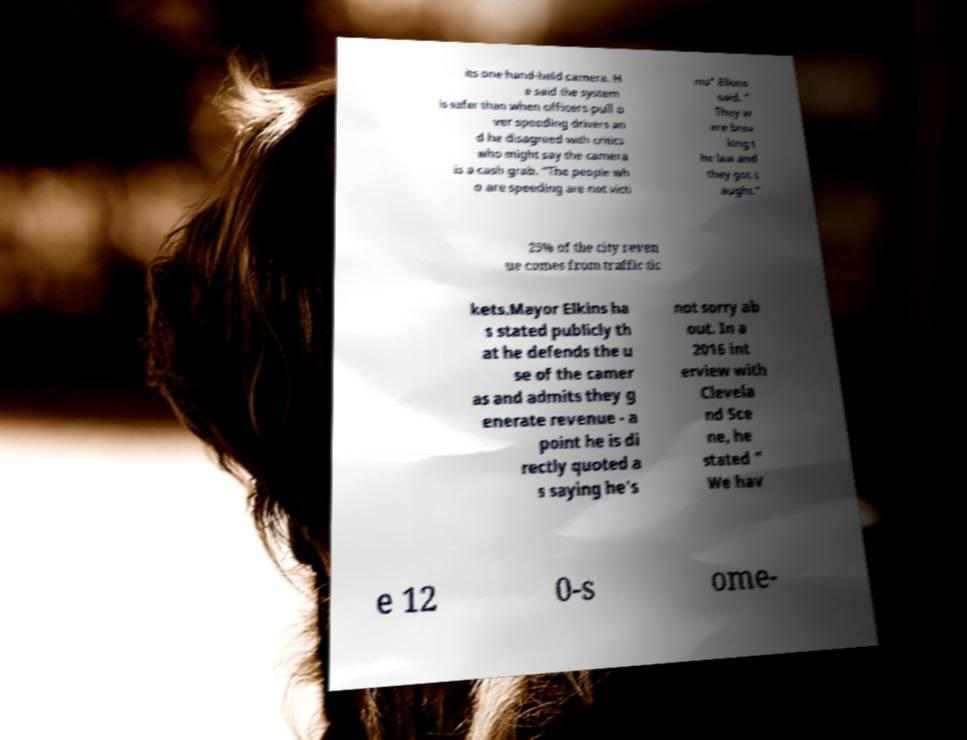Please read and relay the text visible in this image. What does it say? its one hand-held camera. H e said the system is safer than when officers pull o ver speeding drivers an d he disagreed with critics who might say the camera is a cash grab. "The people wh o are speeding are not victi ms" Elkins said. " They w ere brea king t he law and they got c aught." 25% of the city reven ue comes from traffic tic kets.Mayor Elkins ha s stated publicly th at he defends the u se of the camer as and admits they g enerate revenue - a point he is di rectly quoted a s saying he's not sorry ab out. In a 2016 int erview with Clevela nd Sce ne, he stated " We hav e 12 0-s ome- 